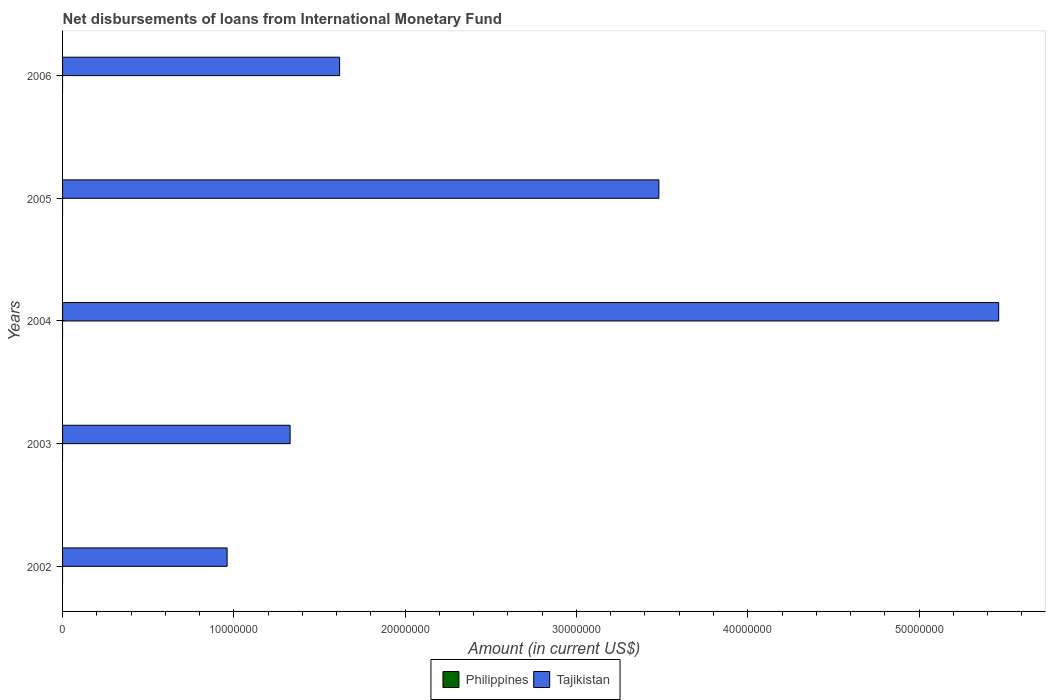How many different coloured bars are there?
Offer a very short reply. 1. What is the label of the 5th group of bars from the top?
Keep it short and to the point. 2002. In how many cases, is the number of bars for a given year not equal to the number of legend labels?
Give a very brief answer. 5. What is the amount of loans disbursed in Tajikistan in 2004?
Offer a terse response. 5.46e+07. Across all years, what is the maximum amount of loans disbursed in Tajikistan?
Keep it short and to the point. 5.46e+07. What is the total amount of loans disbursed in Tajikistan in the graph?
Give a very brief answer. 1.29e+08. What is the difference between the amount of loans disbursed in Tajikistan in 2003 and that in 2005?
Offer a terse response. -2.15e+07. What is the difference between the amount of loans disbursed in Philippines in 2005 and the amount of loans disbursed in Tajikistan in 2003?
Keep it short and to the point. -1.33e+07. What is the average amount of loans disbursed in Philippines per year?
Your answer should be compact. 0. In how many years, is the amount of loans disbursed in Tajikistan greater than 34000000 US$?
Ensure brevity in your answer.  2. What is the ratio of the amount of loans disbursed in Tajikistan in 2004 to that in 2005?
Ensure brevity in your answer.  1.57. What is the difference between the highest and the second highest amount of loans disbursed in Tajikistan?
Keep it short and to the point. 1.98e+07. What is the difference between the highest and the lowest amount of loans disbursed in Tajikistan?
Your response must be concise. 4.50e+07. In how many years, is the amount of loans disbursed in Philippines greater than the average amount of loans disbursed in Philippines taken over all years?
Your answer should be very brief. 0. Is the sum of the amount of loans disbursed in Tajikistan in 2002 and 2004 greater than the maximum amount of loans disbursed in Philippines across all years?
Provide a succinct answer. Yes. What is the difference between two consecutive major ticks on the X-axis?
Provide a succinct answer. 1.00e+07. Are the values on the major ticks of X-axis written in scientific E-notation?
Ensure brevity in your answer.  No. Does the graph contain grids?
Give a very brief answer. No. Where does the legend appear in the graph?
Offer a terse response. Bottom center. How many legend labels are there?
Give a very brief answer. 2. What is the title of the graph?
Provide a short and direct response. Net disbursements of loans from International Monetary Fund. Does "Korea (Democratic)" appear as one of the legend labels in the graph?
Offer a terse response. No. What is the Amount (in current US$) in Tajikistan in 2002?
Give a very brief answer. 9.60e+06. What is the Amount (in current US$) in Tajikistan in 2003?
Give a very brief answer. 1.33e+07. What is the Amount (in current US$) in Tajikistan in 2004?
Give a very brief answer. 5.46e+07. What is the Amount (in current US$) in Philippines in 2005?
Your answer should be compact. 0. What is the Amount (in current US$) of Tajikistan in 2005?
Keep it short and to the point. 3.48e+07. What is the Amount (in current US$) of Philippines in 2006?
Offer a very short reply. 0. What is the Amount (in current US$) in Tajikistan in 2006?
Provide a succinct answer. 1.62e+07. Across all years, what is the maximum Amount (in current US$) in Tajikistan?
Your answer should be compact. 5.46e+07. Across all years, what is the minimum Amount (in current US$) of Tajikistan?
Offer a terse response. 9.60e+06. What is the total Amount (in current US$) in Philippines in the graph?
Offer a terse response. 0. What is the total Amount (in current US$) in Tajikistan in the graph?
Offer a very short reply. 1.29e+08. What is the difference between the Amount (in current US$) of Tajikistan in 2002 and that in 2003?
Give a very brief answer. -3.68e+06. What is the difference between the Amount (in current US$) in Tajikistan in 2002 and that in 2004?
Make the answer very short. -4.50e+07. What is the difference between the Amount (in current US$) of Tajikistan in 2002 and that in 2005?
Your response must be concise. -2.52e+07. What is the difference between the Amount (in current US$) in Tajikistan in 2002 and that in 2006?
Your answer should be very brief. -6.57e+06. What is the difference between the Amount (in current US$) of Tajikistan in 2003 and that in 2004?
Make the answer very short. -4.14e+07. What is the difference between the Amount (in current US$) in Tajikistan in 2003 and that in 2005?
Offer a terse response. -2.15e+07. What is the difference between the Amount (in current US$) of Tajikistan in 2003 and that in 2006?
Your answer should be very brief. -2.89e+06. What is the difference between the Amount (in current US$) of Tajikistan in 2004 and that in 2005?
Keep it short and to the point. 1.98e+07. What is the difference between the Amount (in current US$) of Tajikistan in 2004 and that in 2006?
Provide a short and direct response. 3.85e+07. What is the difference between the Amount (in current US$) in Tajikistan in 2005 and that in 2006?
Offer a terse response. 1.86e+07. What is the average Amount (in current US$) in Tajikistan per year?
Give a very brief answer. 2.57e+07. What is the ratio of the Amount (in current US$) in Tajikistan in 2002 to that in 2003?
Offer a terse response. 0.72. What is the ratio of the Amount (in current US$) in Tajikistan in 2002 to that in 2004?
Make the answer very short. 0.18. What is the ratio of the Amount (in current US$) in Tajikistan in 2002 to that in 2005?
Your answer should be very brief. 0.28. What is the ratio of the Amount (in current US$) in Tajikistan in 2002 to that in 2006?
Provide a short and direct response. 0.59. What is the ratio of the Amount (in current US$) in Tajikistan in 2003 to that in 2004?
Your answer should be very brief. 0.24. What is the ratio of the Amount (in current US$) of Tajikistan in 2003 to that in 2005?
Offer a very short reply. 0.38. What is the ratio of the Amount (in current US$) in Tajikistan in 2003 to that in 2006?
Your answer should be compact. 0.82. What is the ratio of the Amount (in current US$) of Tajikistan in 2004 to that in 2005?
Your response must be concise. 1.57. What is the ratio of the Amount (in current US$) in Tajikistan in 2004 to that in 2006?
Your answer should be very brief. 3.38. What is the ratio of the Amount (in current US$) of Tajikistan in 2005 to that in 2006?
Make the answer very short. 2.15. What is the difference between the highest and the second highest Amount (in current US$) of Tajikistan?
Provide a short and direct response. 1.98e+07. What is the difference between the highest and the lowest Amount (in current US$) of Tajikistan?
Provide a succinct answer. 4.50e+07. 